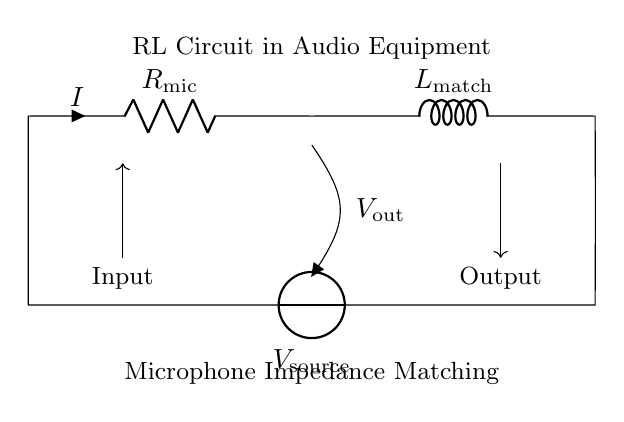What is the value of R in this circuit? The resistor is labeled as R mic, indicating that its function is related to microphone impedance. The actual numerical value isn't provided visually, but its identification is clear.
Answer: R mic What type of circuit is depicted in the diagram? The circuit consists of a resistor and an inductor in series, commonly referred to as an RL circuit. This type is used to manage impedance in audio applications.
Answer: RL circuit What is the main purpose of the inductor in this audio circuit? The inductor, labeled as L match, is used to match impedance between the microphone and the audio source, facilitating better signal transfer and reducing reflections.
Answer: Impedance matching What does the V out label represent? The V out label signifies the output voltage from the RL circuit, which is the voltage across the load connected at the output terminal.
Answer: Output voltage What does the arrow on the V source indicate? The arrow represents the direction of conventional current flow from the voltage source into the circuit, showing how power is supplied to the components.
Answer: Current direction How do the components R mic and L match work together in the circuit? R mic offers a resistive load to the microphone, while L match provides inductive reactance. Together, they form a combination that helps to match the impedance for optimal audio performance.
Answer: Impedance matching 